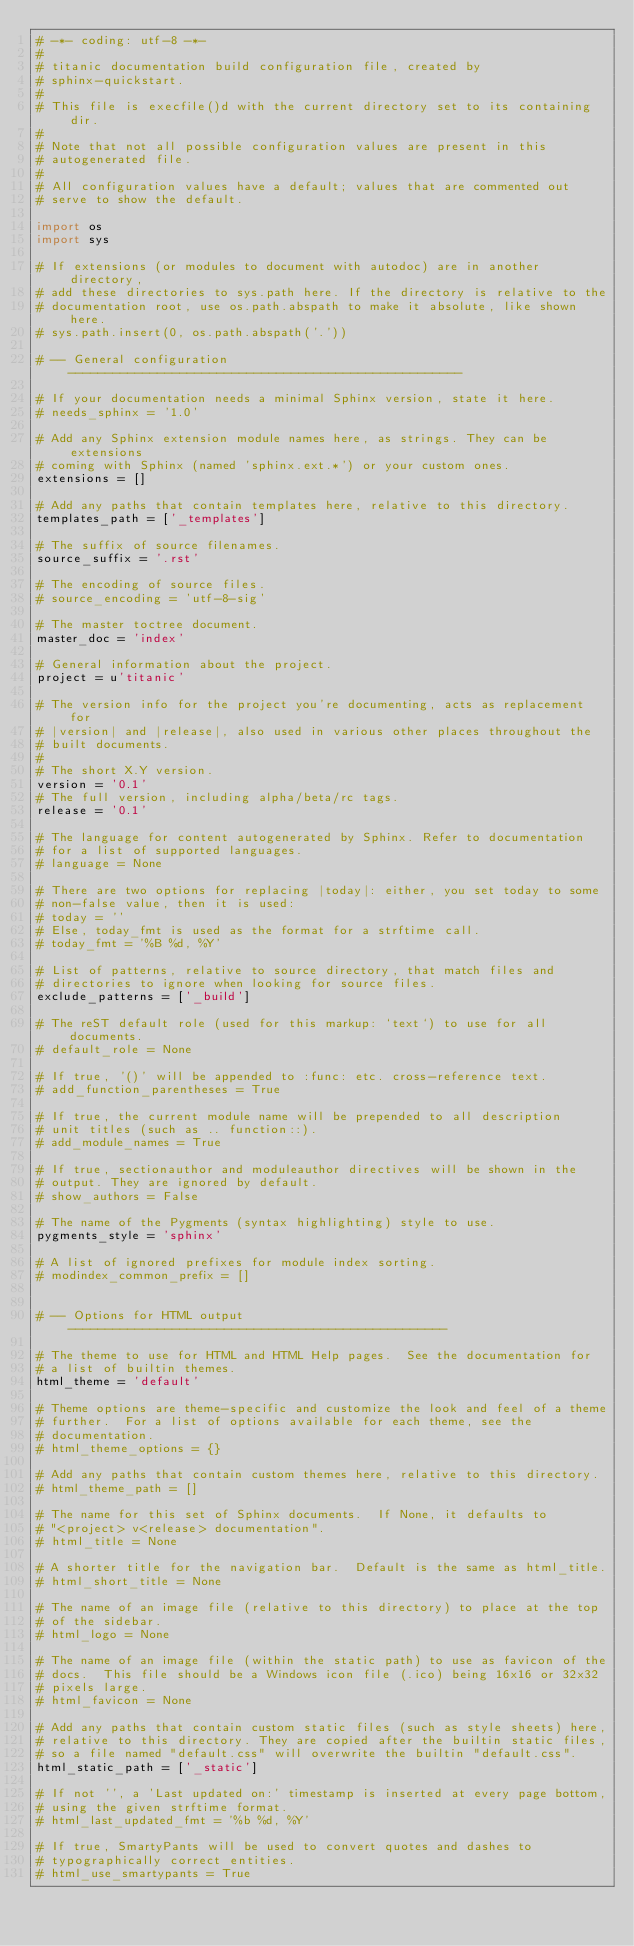Convert code to text. <code><loc_0><loc_0><loc_500><loc_500><_Python_># -*- coding: utf-8 -*-
#
# titanic documentation build configuration file, created by
# sphinx-quickstart.
#
# This file is execfile()d with the current directory set to its containing dir.
#
# Note that not all possible configuration values are present in this
# autogenerated file.
#
# All configuration values have a default; values that are commented out
# serve to show the default.

import os
import sys

# If extensions (or modules to document with autodoc) are in another directory,
# add these directories to sys.path here. If the directory is relative to the
# documentation root, use os.path.abspath to make it absolute, like shown here.
# sys.path.insert(0, os.path.abspath('.'))

# -- General configuration -----------------------------------------------------

# If your documentation needs a minimal Sphinx version, state it here.
# needs_sphinx = '1.0'

# Add any Sphinx extension module names here, as strings. They can be extensions
# coming with Sphinx (named 'sphinx.ext.*') or your custom ones.
extensions = []

# Add any paths that contain templates here, relative to this directory.
templates_path = ['_templates']

# The suffix of source filenames.
source_suffix = '.rst'

# The encoding of source files.
# source_encoding = 'utf-8-sig'

# The master toctree document.
master_doc = 'index'

# General information about the project.
project = u'titanic'

# The version info for the project you're documenting, acts as replacement for
# |version| and |release|, also used in various other places throughout the
# built documents.
#
# The short X.Y version.
version = '0.1'
# The full version, including alpha/beta/rc tags.
release = '0.1'

# The language for content autogenerated by Sphinx. Refer to documentation
# for a list of supported languages.
# language = None

# There are two options for replacing |today|: either, you set today to some
# non-false value, then it is used:
# today = ''
# Else, today_fmt is used as the format for a strftime call.
# today_fmt = '%B %d, %Y'

# List of patterns, relative to source directory, that match files and
# directories to ignore when looking for source files.
exclude_patterns = ['_build']

# The reST default role (used for this markup: `text`) to use for all documents.
# default_role = None

# If true, '()' will be appended to :func: etc. cross-reference text.
# add_function_parentheses = True

# If true, the current module name will be prepended to all description
# unit titles (such as .. function::).
# add_module_names = True

# If true, sectionauthor and moduleauthor directives will be shown in the
# output. They are ignored by default.
# show_authors = False

# The name of the Pygments (syntax highlighting) style to use.
pygments_style = 'sphinx'

# A list of ignored prefixes for module index sorting.
# modindex_common_prefix = []


# -- Options for HTML output ---------------------------------------------------

# The theme to use for HTML and HTML Help pages.  See the documentation for
# a list of builtin themes.
html_theme = 'default'

# Theme options are theme-specific and customize the look and feel of a theme
# further.  For a list of options available for each theme, see the
# documentation.
# html_theme_options = {}

# Add any paths that contain custom themes here, relative to this directory.
# html_theme_path = []

# The name for this set of Sphinx documents.  If None, it defaults to
# "<project> v<release> documentation".
# html_title = None

# A shorter title for the navigation bar.  Default is the same as html_title.
# html_short_title = None

# The name of an image file (relative to this directory) to place at the top
# of the sidebar.
# html_logo = None

# The name of an image file (within the static path) to use as favicon of the
# docs.  This file should be a Windows icon file (.ico) being 16x16 or 32x32
# pixels large.
# html_favicon = None

# Add any paths that contain custom static files (such as style sheets) here,
# relative to this directory. They are copied after the builtin static files,
# so a file named "default.css" will overwrite the builtin "default.css".
html_static_path = ['_static']

# If not '', a 'Last updated on:' timestamp is inserted at every page bottom,
# using the given strftime format.
# html_last_updated_fmt = '%b %d, %Y'

# If true, SmartyPants will be used to convert quotes and dashes to
# typographically correct entities.
# html_use_smartypants = True
</code> 